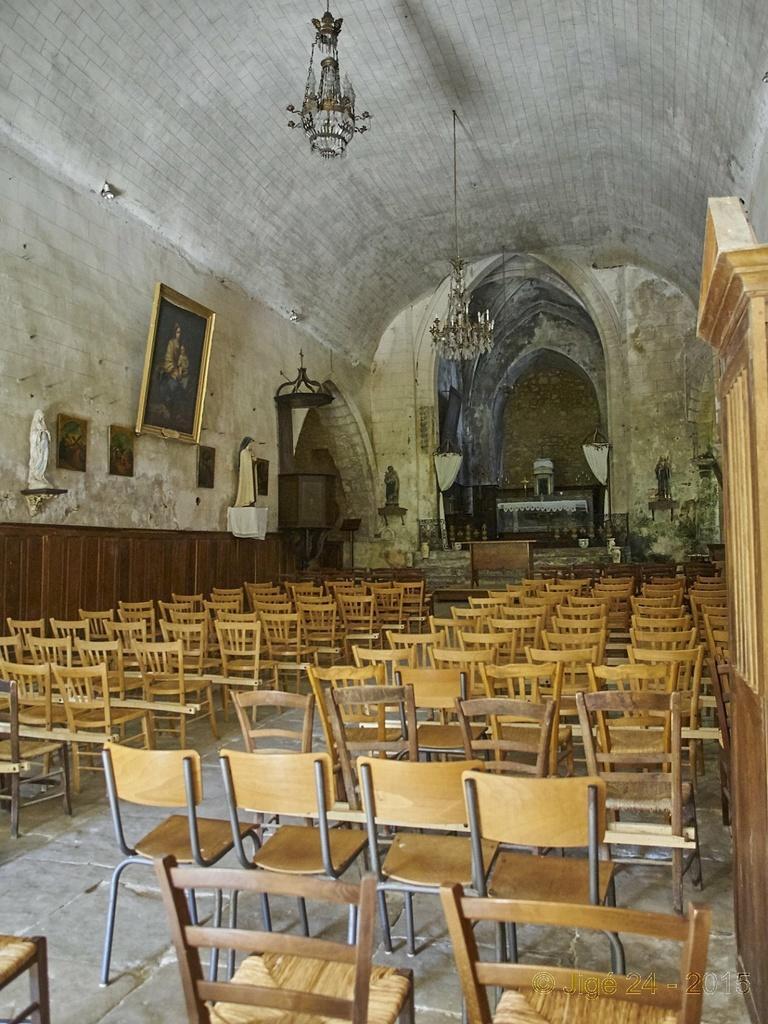Describe this image in one or two sentences. In this image there are some chairs and in the background there are photo frames, chandeliers and table, statue and objects. At the bottom there is floor and at the top there is ceiling. 